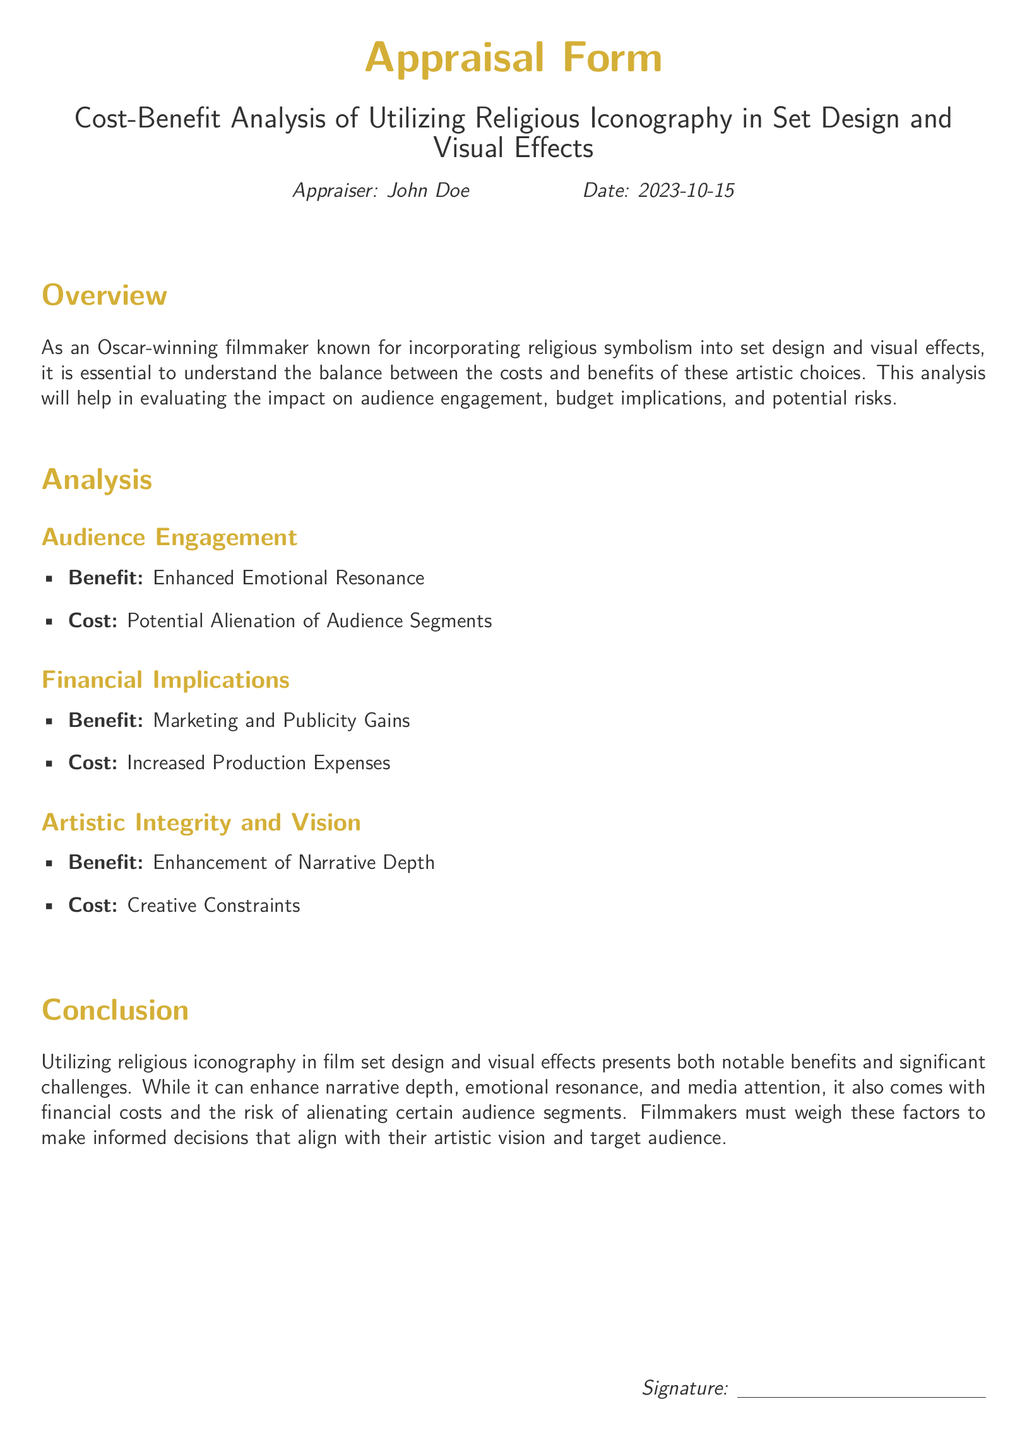What is the document's title? The title is stated at the beginning of the document and reflects the focus of the analysis.
Answer: Cost-Benefit Analysis of Utilizing Religious Iconography in Set Design and Visual Effects Who is the appraiser? The appraiser's name is mentioned in the introduction section of the document.
Answer: John Doe What date is listed on the appraisal form? The date appears next to the appraiser's name and indicates when the analysis was completed.
Answer: 2023-10-15 What is one benefit of utilizing religious iconography? The benefit is highlighted in the Audience Engagement section and emphasizes a positive impact on the audience.
Answer: Enhanced Emotional Resonance What is one cost associated with religious iconography? The cost is mentioned in the Financial Implications section referring to the financial aspects of production.
Answer: Increased Production Expenses What does the analysis seek to enhance? The document outlines the purpose of the appraisal, which reflects its artistic goals.
Answer: Narrative Depth What type of analysis is conducted in this document? The document identifies clearly what kind of analysis is being performed.
Answer: Cost-Benefit Analysis What risk is mentioned in relation to audience engagement? The risk suggests a potential negative reaction from certain audience segments.
Answer: Potential Alienation of Audience Segments 